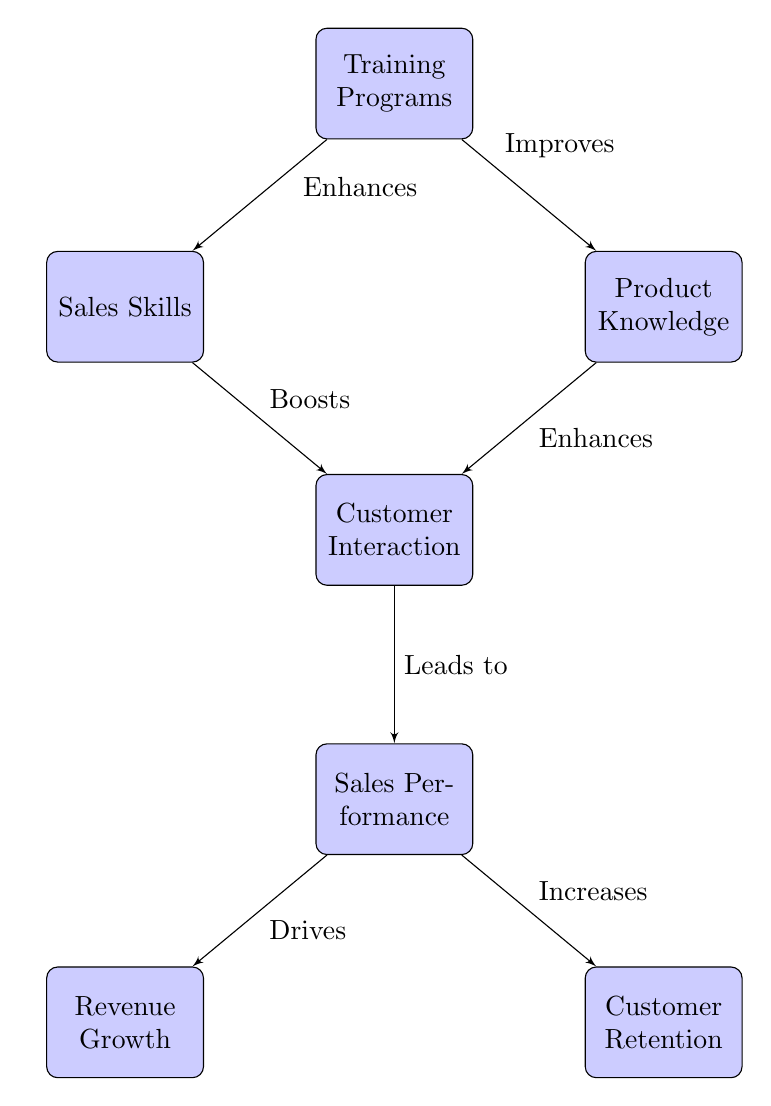What are the two main components that the training programs enhance? The training programs enhance sales skills and product knowledge, as indicated by the two arrows pointing out from the training programs node to these components.
Answer: Sales Skills and Product Knowledge How many nodes are present in the diagram? The diagram consists of seven blocks: Training Programs, Sales Skills, Product Knowledge, Customer Interaction, Sales Performance, Revenue Growth, and Customer Retention. Counting these gives a total of seven nodes.
Answer: 7 What action do sales skills and product knowledge both lead to? Both sales skills and product knowledge contribute to customer interaction, as they have direct arrows pointing to that node from each of them.
Answer: Customer Interaction What is the result of improved customer interaction according to the diagram? Improved customer interaction leads to better sales performance, which is represented by the arrow pointing from customer interaction to sales performance.
Answer: Sales Performance Which two outcomes are driven by sales performance in the diagram? Sales performance drives revenue growth and increases customer retention, which are shown as two separate arrows leading from the sales performance node to both outcomes.
Answer: Revenue Growth and Customer Retention Which component directly connects to customer interaction but not to training programs? The customer interaction node is directly connected to sales skills and product knowledge but does not have a direct connection to training programs.
Answer: Customer Interaction What kind of relationship exists between training programs and product knowledge? The relationship between training programs and product knowledge is that the training programs improve product knowledge, as indicated by the arrow labeled "Improves."
Answer: Improves 